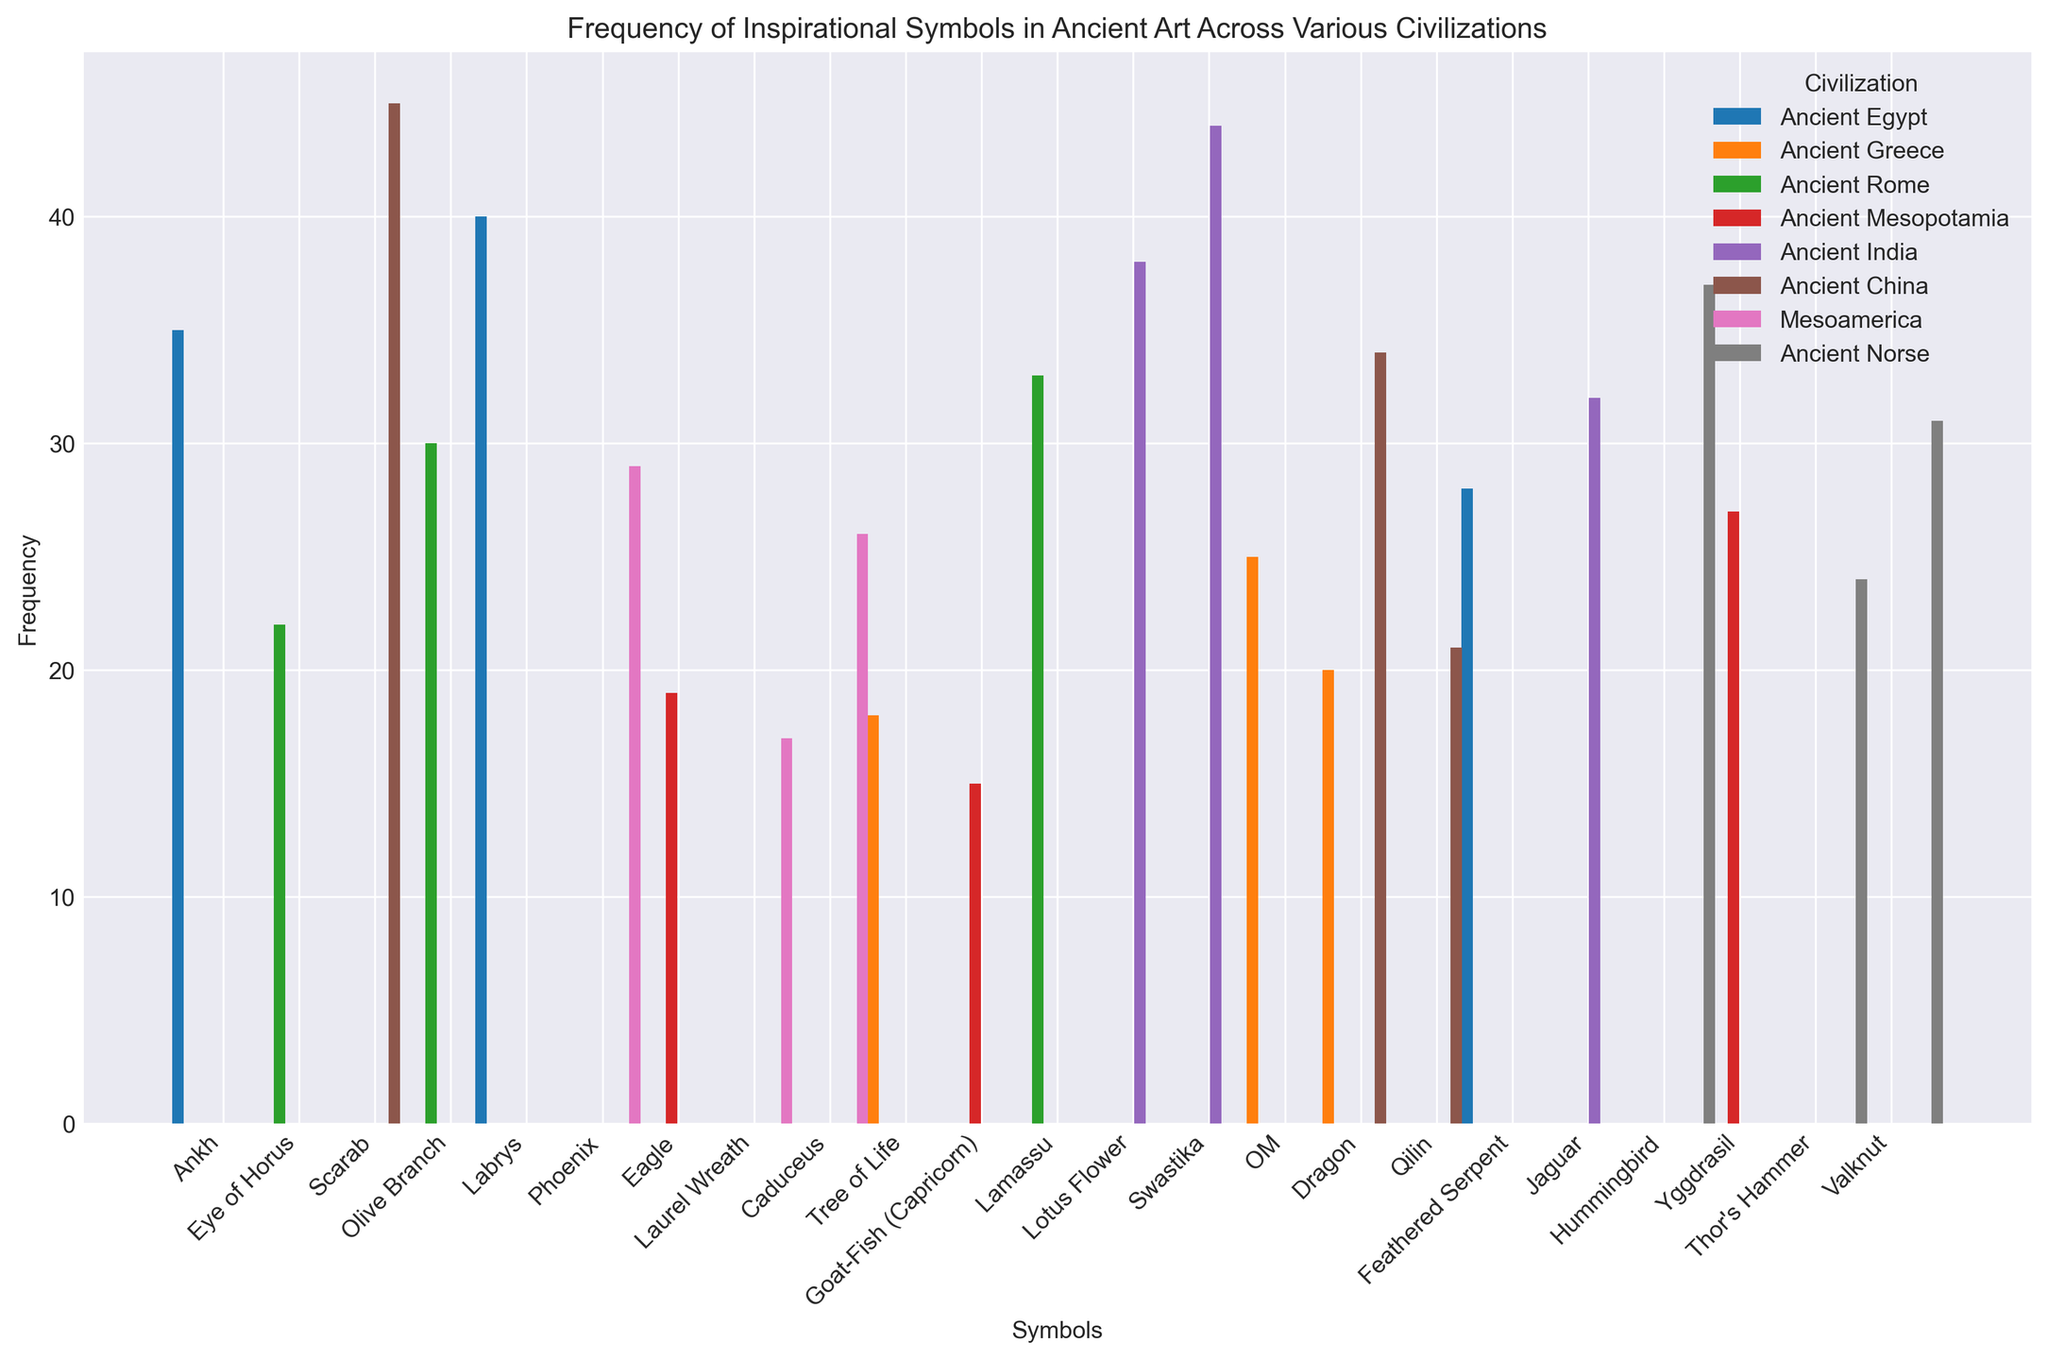Which civilization has the highest frequency symbol overall? By inspecting the bars in the chart, the highest-frequency symbol is with the maximum bar height. The OM symbol from Ancient India has the highest frequency of 44.
Answer: Ancient India Which two symbols have the closest frequencies, and what are their values? Compare the bar heights for all symbols and find the pair of symbols with the smallest difference in frequency. The closest are the Jagular in Mesoamerica with a frequency of 26 and Ankh in Ancient Egypt with a frequency of 35. The difference is 9.
Answer: Jaguar (26) and Ankh (35) What is the total frequency of symbols from the Ancient Rome? Sum the frequencies of the symbols from Ancient Rome: Eagle (30) + Laurel Wreath (33) + Caduceus (22) = 85.
Answer: 85 Which civilization has the least frequently shown symbol, and what is it? Identify the smallest frequency in the chart, then determine which civilization and symbol it corresponds to. The smallest frequency is 15 for the Lamassu symbol in Ancient Mesopotamia.
Answer: Ancient Mesopotamia, Lamassu What is the average frequency of the Ancient Norse symbols? Add the frequencies of the Ancient Norse symbols and then divide by the number of symbols: (Yggdrasil (31) + Thor's Hammer (37) + Valknut (24)) / 3 = 92 / 3 ≈ 30.67.
Answer: ≈30.67 Which civilization has more symbols with a frequency of at least 30? Count the symbols for each civilization with a frequency of at least 30 by checking the heights of the bars: Ancient China (Dragon, Phoenix), and Ancient India (Lotus Flower, Swastika, OM) both have symbols with frequencies of at least 30. Ancient India has the most.
Answer: Ancient India Compare the frequency of the Eye of Horus symbol in Ancient Egypt with the Dragon symbol in Ancient China. Which is higher and by how much? Inspect the heights of the bars corresponding to Eye of Horus (40) and Dragon (45). The Dragon symbol has a higher frequency by 5.
Answer: Dragon by 5 What is the median frequency of all symbols? List all frequencies in order and find the middle value. The ordered frequencies are: 15, 17, 18, 19, 20, 21, 22, 24, 25, 26, 27, 28, 29, 30, 31, 32, 33, 34, 35, 37, 38, 40, 44, 45. The median is the average of the 12th and 13th values: (28 + 29) / 2 = 28.5.
Answer: 28.5 Which symbol appears more frequently in both Ancient Greece and Ancient Rome? Compare the frequencies of symbols that are present in both civilizations. It turns out they don’t have any common symbols, so their comparison isn't applicable.
Answer: Not applicable 